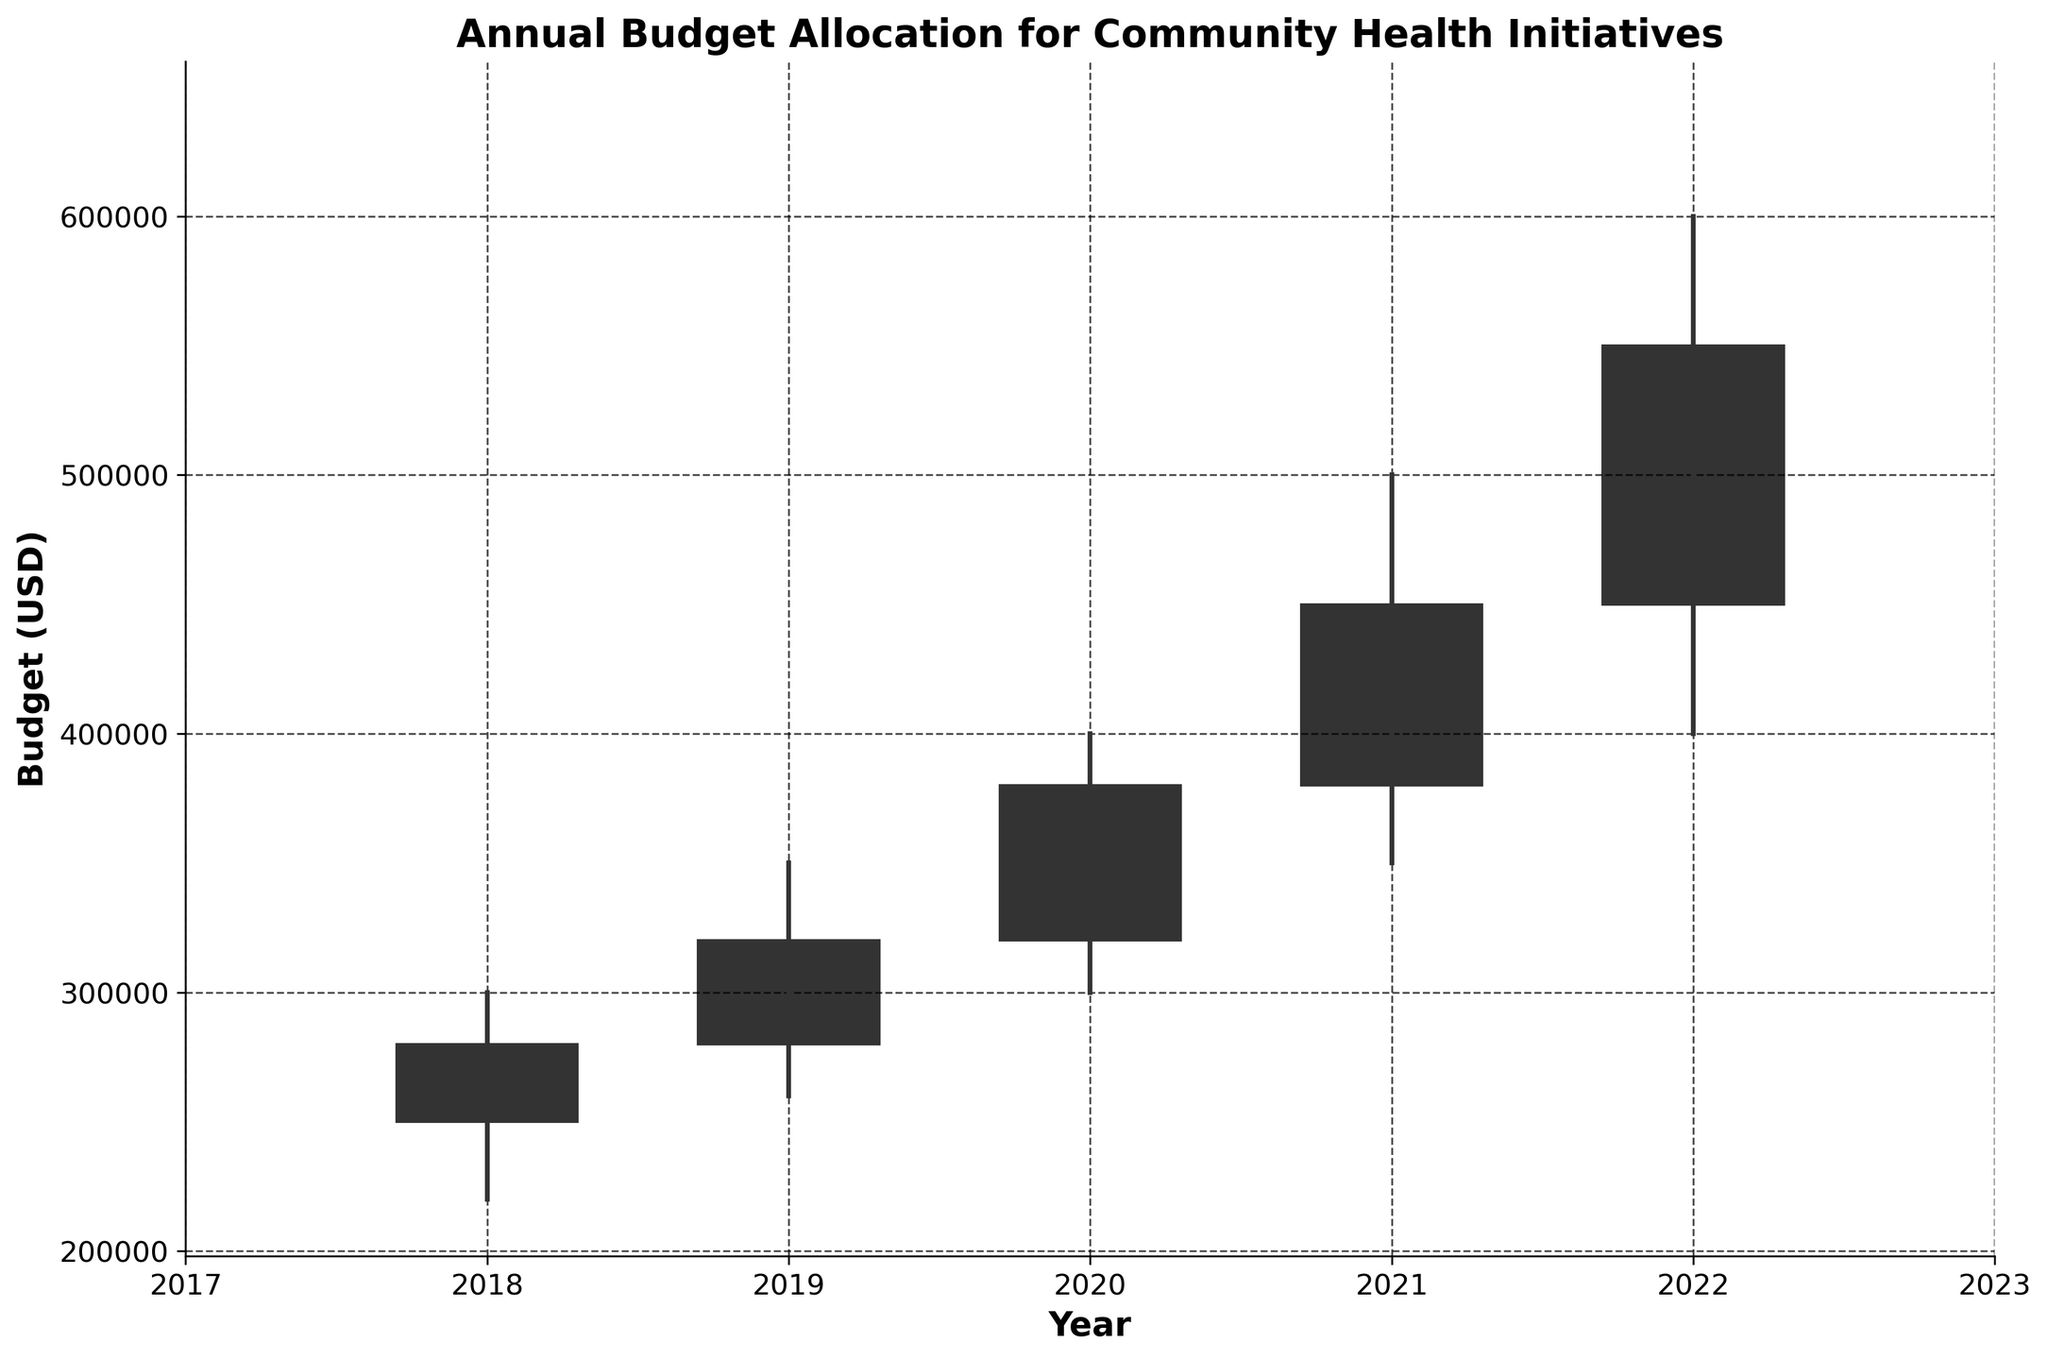What is the title of the chart? The title is written at the top of the figure and it reads "Annual Budget Allocation for Community Health Initiatives".
Answer: Annual Budget Allocation for Community Health Initiatives How many years are covered in the chart? The x-axis shows the years, and there are ticks for each year from 2018 to 2022.
Answer: 5 What was the initial budget allocation in 2018? The chart shows the initial budget for each year, and for 2018, it is represented as the bottom of the rectangular bar for that year.
Answer: 250000 What was the maximum budget allocation in 2020? The highest point of the vertical line above the rectangular bar for 2020 represents the maximum budget allocation.
Answer: 400000 In which year did the minimum budget allocation reach 350000? The lowest point of the vertical line connected to the rectangular bar in 2021 indicates that year's minimum budget allocation.
Answer: 2021 By how much did the final budget allocation increase from 2021 to 2022? The final budget allocation for each year is marked by the top or bottom of the rectangular bar. From 2021 to 2022, the final budget allocation increased from 450000 to 550000. The difference is calculated as 550000 - 450000.
Answer: 100000 Which year had the smallest budget range (maximum - minimum)? For each year, subtract the minimum value (bottom of the line) from the maximum value (top of the line). The smallest range is the difference for the year 2018: 300000 - 220000.
Answer: 2018 How did the final budget allocation in 2020 compare to the initial budget allocation in 2022? Compare the final value of 2020 (top of the bar) to the initial value of 2022 (bottom of the bar). The final value in 2020 is 380000, and the initial value in 2022 is 450000, so the latter is higher.
Answer: The initial budget allocation in 2022 was higher What was the average initial budget allocation from 2018 to 2022? Add the initial budget allocations for each year (250000, 280000, 320000, 380000, 450000) and divide by the number of years (5). The sum is 1680000, and the average is 1680000 / 5.
Answer: 336000 In which year did the final budget allocation exceed the maximum budget allocation of the previous year? Compare the final budget of each year to the maximum budget of the prior year. In 2022, the final budget allocation (550000) exceeded the maximum budget allocation in 2021 (500000).
Answer: 2022 